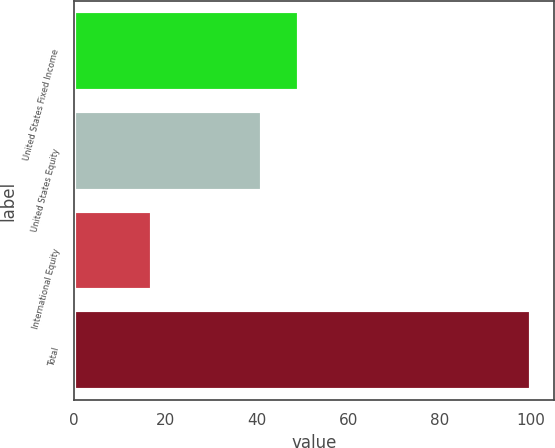<chart> <loc_0><loc_0><loc_500><loc_500><bar_chart><fcel>United States Fixed Income<fcel>United States Equity<fcel>International Equity<fcel>Total<nl><fcel>49.3<fcel>41<fcel>17<fcel>100<nl></chart> 